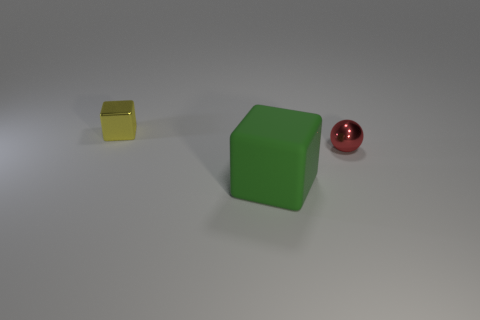How many things are things that are to the right of the matte object or metallic balls?
Your answer should be compact. 1. How many other objects are there of the same size as the yellow block?
Keep it short and to the point. 1. Are there an equal number of blocks that are behind the matte cube and small objects that are to the left of the small red shiny thing?
Provide a short and direct response. Yes. What is the color of the other metal object that is the same shape as the large green object?
Your response must be concise. Yellow. Is there any other thing that has the same shape as the green matte thing?
Your answer should be compact. Yes. There is a tiny thing in front of the small cube; is it the same color as the tiny shiny block?
Your response must be concise. No. What size is the green thing that is the same shape as the small yellow object?
Your answer should be very brief. Large. How many objects are the same material as the sphere?
Offer a terse response. 1. Are there any yellow metal cubes left of the tiny metallic object behind the metal object that is to the right of the matte object?
Provide a short and direct response. No. What is the shape of the green matte thing?
Your answer should be compact. Cube. 